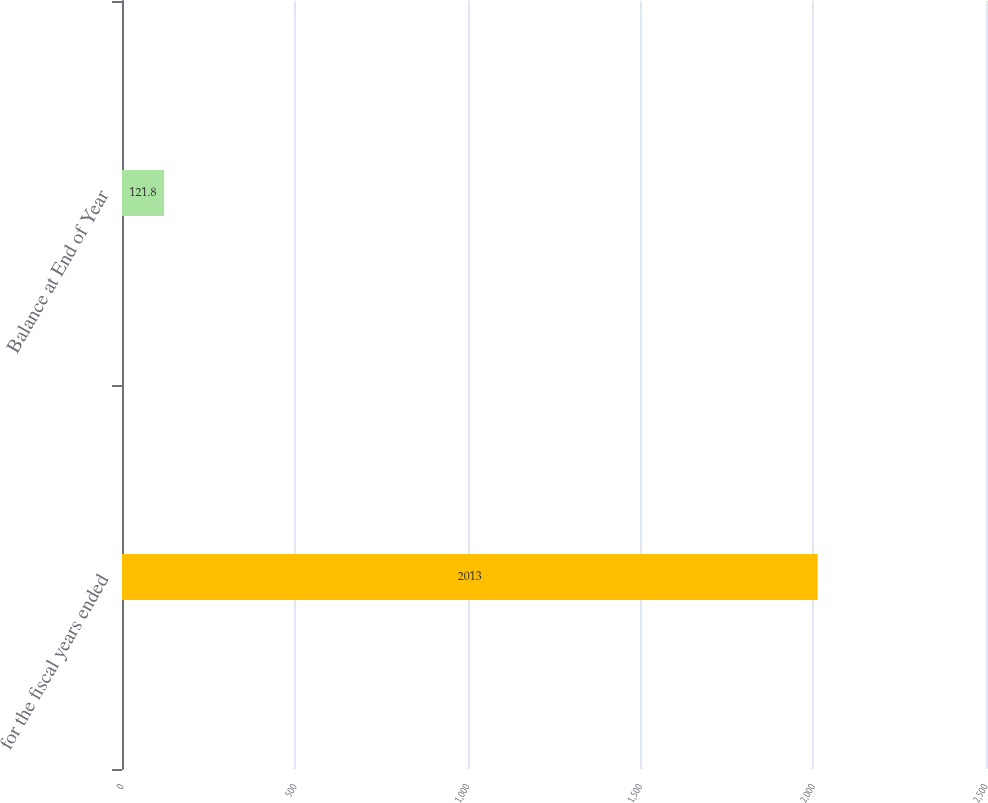Convert chart to OTSL. <chart><loc_0><loc_0><loc_500><loc_500><bar_chart><fcel>for the fiscal years ended<fcel>Balance at End of Year<nl><fcel>2013<fcel>121.8<nl></chart> 